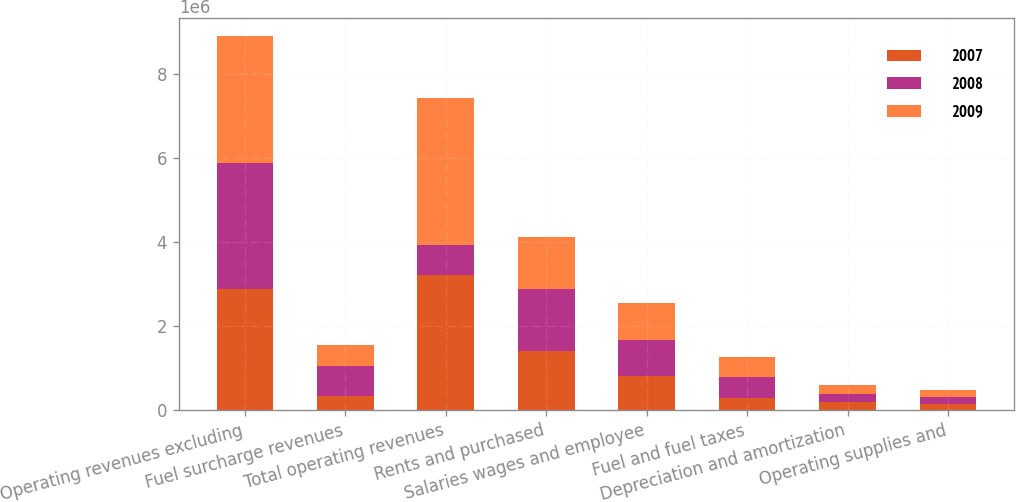Convert chart to OTSL. <chart><loc_0><loc_0><loc_500><loc_500><stacked_bar_chart><ecel><fcel>Operating revenues excluding<fcel>Fuel surcharge revenues<fcel>Total operating revenues<fcel>Rents and purchased<fcel>Salaries wages and employee<fcel>Fuel and fuel taxes<fcel>Depreciation and amortization<fcel>Operating supplies and<nl><fcel>2007<fcel>2.87705e+06<fcel>326269<fcel>3.20332e+06<fcel>1.39811e+06<fcel>798272<fcel>273521<fcel>189045<fcel>151887<nl><fcel>2008<fcel>3.00153e+06<fcel>730412<fcel>730412<fcel>1.47923e+06<fcel>859588<fcel>520647<fcel>202288<fcel>158202<nl><fcel>2009<fcel>3.00982e+06<fcel>480080<fcel>3.4899e+06<fcel>1.23539e+06<fcel>888594<fcel>463538<fcel>205133<fcel>155893<nl></chart> 